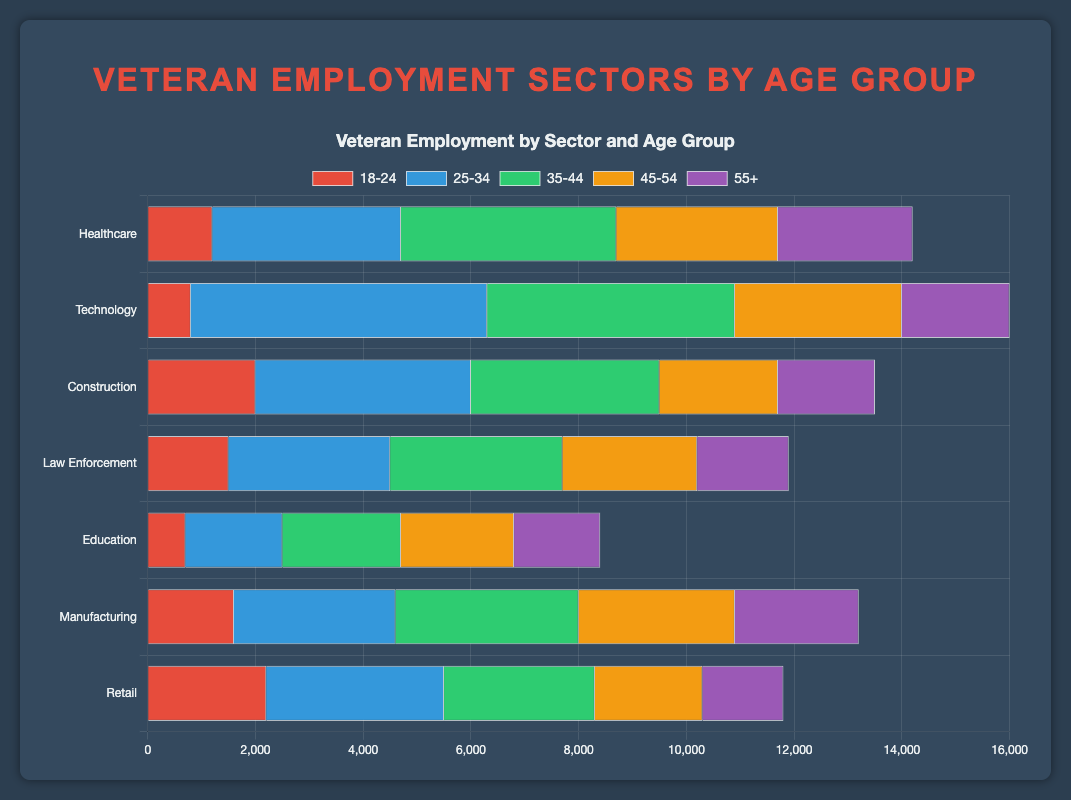What's the total number of veterans employed in the Healthcare sector across all age groups? To find the total number of veterans in the Healthcare sector, sum the values for all age groups: 1200 (18-24) + 3500 (25-34) + 4000 (35-44) + 3000 (45-54) + 2500 (55+). Therefore, the total is 1200 + 3500 + 4000 + 3000 + 2500 = 14200.
Answer: 14200 Which sector has the highest number of veterans in the 25-34 age group? Compare the numbers across all sectors for the 25-34 age group: Healthcare (3500), Technology (5500), Construction (4000), Law Enforcement (3000), Education (1800), Manufacturing (3000), Retail (3300). The highest number is 5500 in the Technology sector.
Answer: Technology How many more veterans aged 45-54 are employed in the Manufacturing sector compared to the Education sector? Subtract the number of veterans aged 45-54 in Education (2100) from the number in Manufacturing (2900): 2900 - 2100 = 800.
Answer: 800 In which sector are the least number of veterans aged 18-24 employed? Compare the numbers for the 18-24 age group across all sectors: Healthcare (1200), Technology (800), Construction (2000), Law Enforcement (1500), Education (700), Manufacturing (1600), Retail (2200). The least number is 700 in the Education sector.
Answer: Education What is the average number of veterans employed across all sectors in the 55+ age group? Sum the values for the 55+ age group in all sectors: Healthcare (2500) + Technology (2000) + Construction (1800) + Law Enforcement (1700) + Education (1600) + Manufacturing (2300) + Retail (1500) = 13400. Divide by the number of sectors, which is 7: 13400 / 7 ≈ 1914.29.
Answer: 1914.29 Which age group has the highest number of veterans employed in the Technology sector? Compare the numbers within the Technology sector: 18-24 (800), 25-34 (5500), 35-44 (4600), 45-54 (3100), 55+ (2000). The highest number is 5500 in the 25-34 age group.
Answer: 25-34 Is the number of veterans employed in the Construction sector for the age group 18-24 greater than that in Law Enforcement for the same age group? Compare the numbers for Construction (2000) and Law Enforcement (1500) in the 18-24 age group. 2000 is greater than 1500.
Answer: Yes What is the difference in the number of veterans aged 35-44 between the Retail and Healthcare sectors? Subtract the number of veterans aged 35-44 in the Retail sector (2800) from that in the Healthcare sector (4000): 4000 - 2800 = 1200.
Answer: 1200 Which sector has the second highest number of veterans in the 45-54 age group, and what is that number? Compare the values for each sector: Healthcare (3000), Technology (3100), Construction (2200), Law Enforcement (2500), Education (2100), Manufacturing (2900), Retail (2000). The second highest is Healthcare (3000), as Technology has the highest (3100).
Answer: Healthcare, 3000 